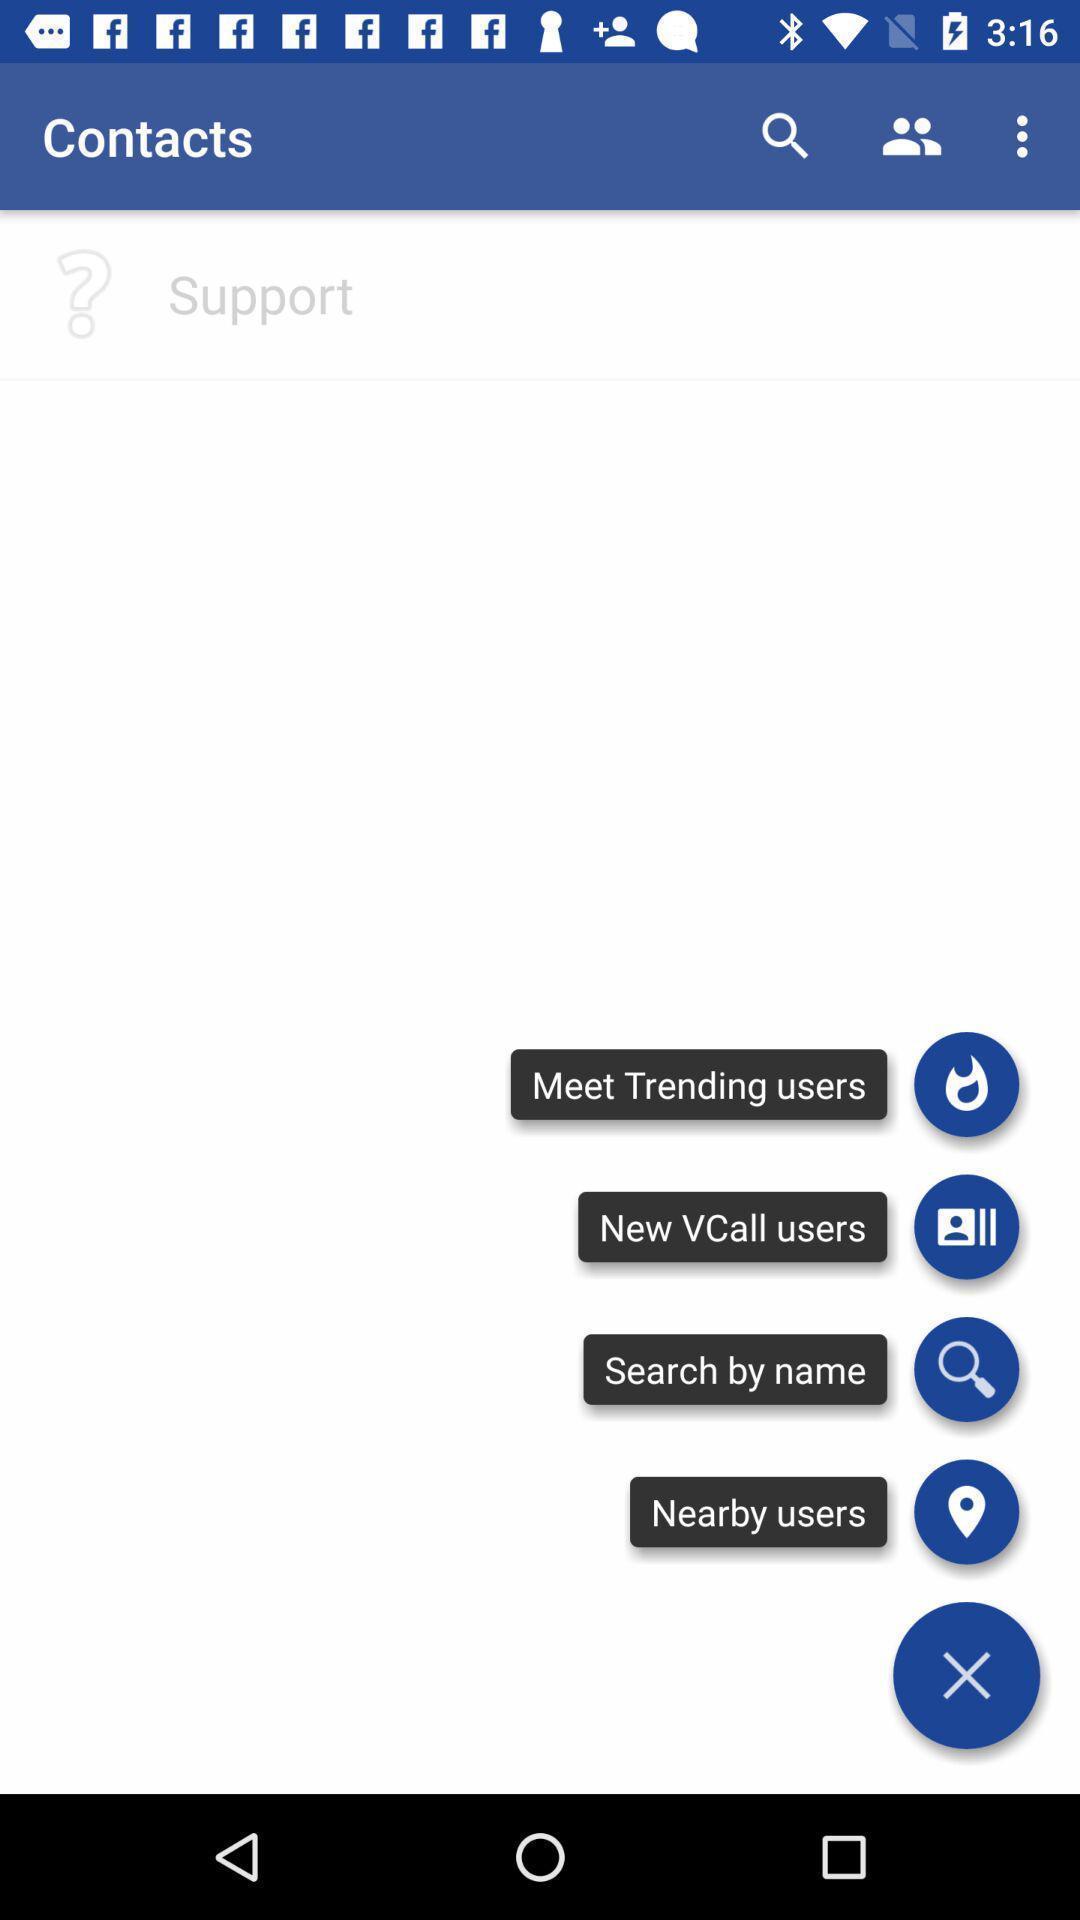Tell me about the visual elements in this screen capture. Screen showing contacts with options. 